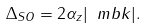<formula> <loc_0><loc_0><loc_500><loc_500>\Delta _ { S O } = 2 \alpha _ { z } | \ m b { k } | .</formula> 